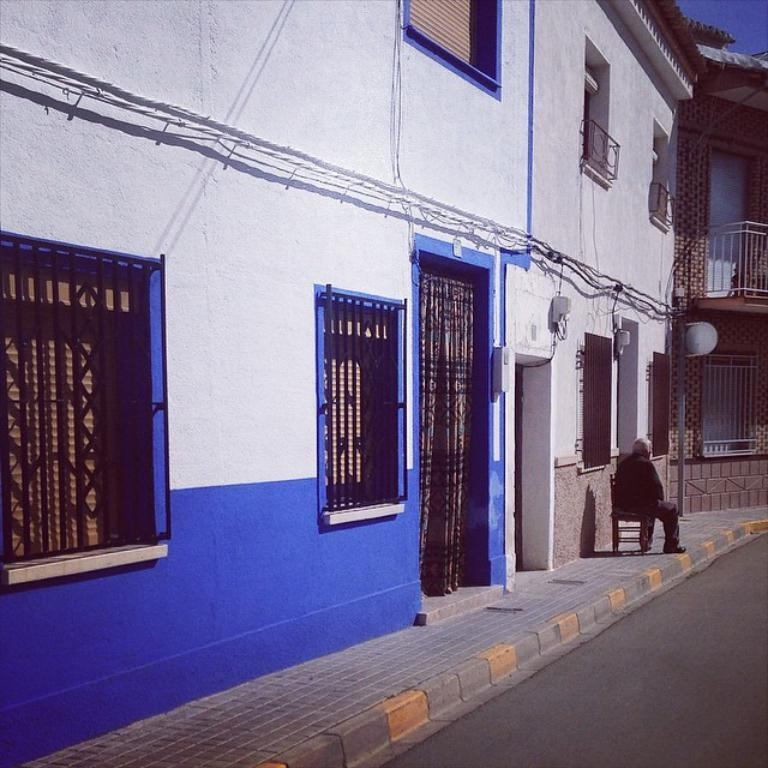What is the person in the image doing? The person is sitting on a footpath on a chair. What can be seen in the background of the image? There is a building in the image. What is in front of the building? There is a road in front of the building. What type of nut is being used as bait for the person sitting on the footpath? There is no nut or bait present in the image; the person is simply sitting on a chair. 